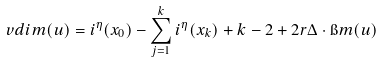<formula> <loc_0><loc_0><loc_500><loc_500>v d i m ( u ) = i ^ { \eta } ( x _ { 0 } ) - \sum _ { j = 1 } ^ { k } i ^ { \eta } ( x _ { k } ) + k - 2 + 2 r \Delta \cdot \i m ( u )</formula> 